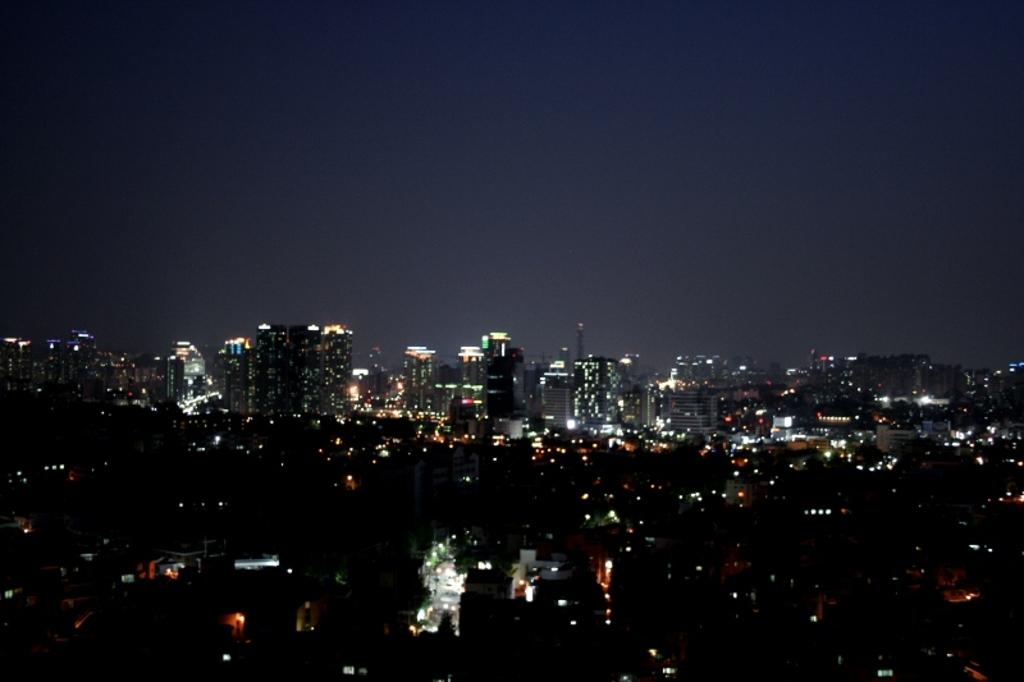What type of structures are present in the image? There are buildings in the image. What can be seen illuminated in the image? There are lights visible in the image. How would you describe the appearance of the sky in the image? The sky appears dark in the image. Can you see any goldfish swimming in the image? There are no goldfish present in the image. What type of coastline can be seen in the image? There is no coastline visible in the image. 